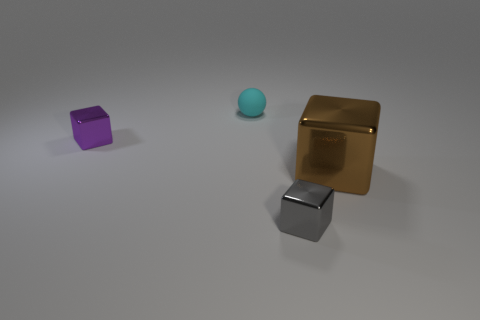Add 4 small cyan matte things. How many objects exist? 8 Subtract all spheres. How many objects are left? 3 Add 1 rubber things. How many rubber things exist? 2 Subtract 1 gray blocks. How many objects are left? 3 Subtract all yellow blocks. Subtract all matte balls. How many objects are left? 3 Add 3 large things. How many large things are left? 4 